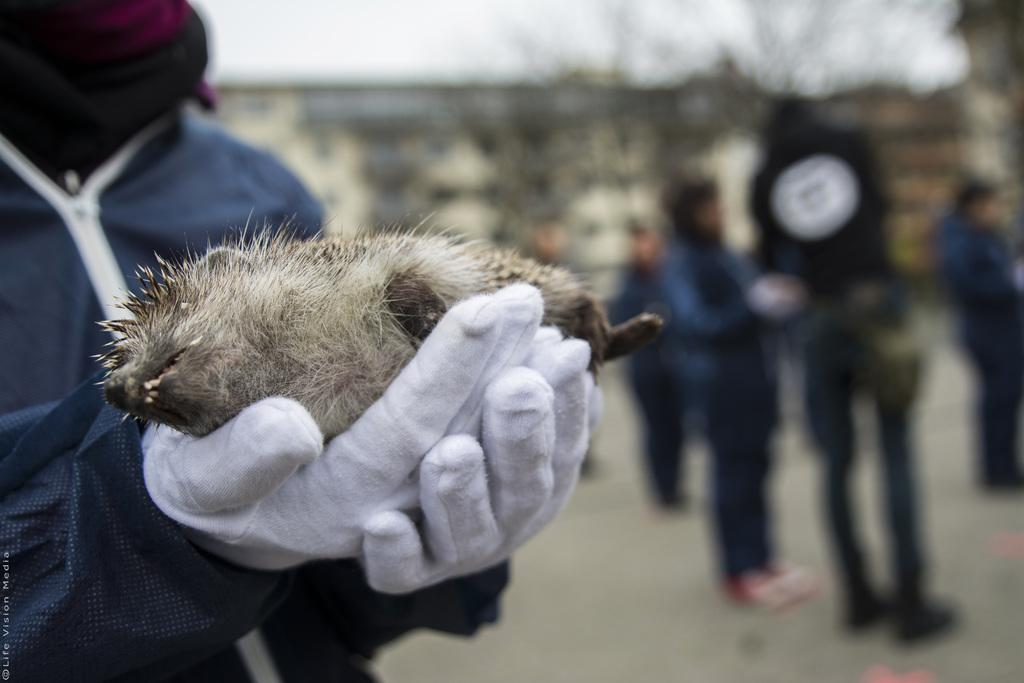What is the position of the person in the image? There is a person standing on the left side of the image. What is the person holding in his hand? The person is holding something in his hand. How many people are standing on the right side of the image? There are people standing on the right side of the image. Can you describe the background of the image? The background of the image is blurred. What type of giants can be seen in the image? There are no giants present in the image. What is the title of the image? The image does not have a title. 